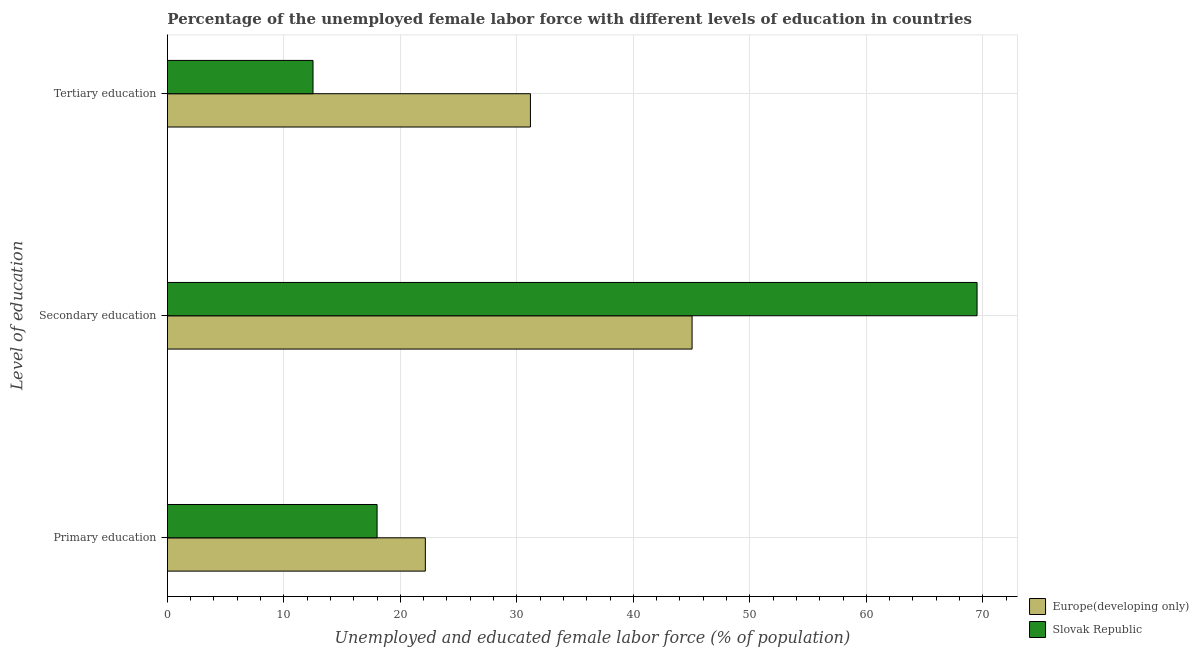How many different coloured bars are there?
Provide a short and direct response. 2. How many bars are there on the 3rd tick from the top?
Provide a succinct answer. 2. How many bars are there on the 2nd tick from the bottom?
Ensure brevity in your answer.  2. What is the percentage of female labor force who received tertiary education in Europe(developing only)?
Make the answer very short. 31.16. Across all countries, what is the maximum percentage of female labor force who received primary education?
Your answer should be compact. 22.14. In which country was the percentage of female labor force who received secondary education maximum?
Your answer should be very brief. Slovak Republic. In which country was the percentage of female labor force who received primary education minimum?
Make the answer very short. Slovak Republic. What is the total percentage of female labor force who received primary education in the graph?
Your answer should be very brief. 40.14. What is the difference between the percentage of female labor force who received tertiary education in Slovak Republic and that in Europe(developing only)?
Offer a terse response. -18.66. What is the difference between the percentage of female labor force who received tertiary education in Europe(developing only) and the percentage of female labor force who received secondary education in Slovak Republic?
Provide a short and direct response. -38.34. What is the average percentage of female labor force who received tertiary education per country?
Ensure brevity in your answer.  21.83. What is the difference between the percentage of female labor force who received secondary education and percentage of female labor force who received tertiary education in Europe(developing only)?
Your answer should be compact. 13.87. In how many countries, is the percentage of female labor force who received primary education greater than 34 %?
Your response must be concise. 0. What is the ratio of the percentage of female labor force who received tertiary education in Europe(developing only) to that in Slovak Republic?
Provide a succinct answer. 2.49. Is the percentage of female labor force who received primary education in Europe(developing only) less than that in Slovak Republic?
Provide a succinct answer. No. What is the difference between the highest and the second highest percentage of female labor force who received primary education?
Ensure brevity in your answer.  4.14. What is the difference between the highest and the lowest percentage of female labor force who received tertiary education?
Ensure brevity in your answer.  18.66. In how many countries, is the percentage of female labor force who received primary education greater than the average percentage of female labor force who received primary education taken over all countries?
Keep it short and to the point. 1. What does the 1st bar from the top in Tertiary education represents?
Your response must be concise. Slovak Republic. What does the 2nd bar from the bottom in Secondary education represents?
Offer a terse response. Slovak Republic. Is it the case that in every country, the sum of the percentage of female labor force who received primary education and percentage of female labor force who received secondary education is greater than the percentage of female labor force who received tertiary education?
Your answer should be compact. Yes. How many bars are there?
Provide a succinct answer. 6. How many countries are there in the graph?
Offer a terse response. 2. Does the graph contain any zero values?
Your answer should be very brief. No. What is the title of the graph?
Offer a terse response. Percentage of the unemployed female labor force with different levels of education in countries. What is the label or title of the X-axis?
Give a very brief answer. Unemployed and educated female labor force (% of population). What is the label or title of the Y-axis?
Your answer should be compact. Level of education. What is the Unemployed and educated female labor force (% of population) of Europe(developing only) in Primary education?
Provide a succinct answer. 22.14. What is the Unemployed and educated female labor force (% of population) in Slovak Republic in Primary education?
Offer a terse response. 18. What is the Unemployed and educated female labor force (% of population) in Europe(developing only) in Secondary education?
Your response must be concise. 45.04. What is the Unemployed and educated female labor force (% of population) of Slovak Republic in Secondary education?
Ensure brevity in your answer.  69.5. What is the Unemployed and educated female labor force (% of population) of Europe(developing only) in Tertiary education?
Provide a short and direct response. 31.16. Across all Level of education, what is the maximum Unemployed and educated female labor force (% of population) in Europe(developing only)?
Your response must be concise. 45.04. Across all Level of education, what is the maximum Unemployed and educated female labor force (% of population) in Slovak Republic?
Your response must be concise. 69.5. Across all Level of education, what is the minimum Unemployed and educated female labor force (% of population) in Europe(developing only)?
Your response must be concise. 22.14. What is the total Unemployed and educated female labor force (% of population) of Europe(developing only) in the graph?
Offer a terse response. 98.34. What is the difference between the Unemployed and educated female labor force (% of population) in Europe(developing only) in Primary education and that in Secondary education?
Offer a very short reply. -22.9. What is the difference between the Unemployed and educated female labor force (% of population) of Slovak Republic in Primary education and that in Secondary education?
Keep it short and to the point. -51.5. What is the difference between the Unemployed and educated female labor force (% of population) in Europe(developing only) in Primary education and that in Tertiary education?
Give a very brief answer. -9.02. What is the difference between the Unemployed and educated female labor force (% of population) in Slovak Republic in Primary education and that in Tertiary education?
Your response must be concise. 5.5. What is the difference between the Unemployed and educated female labor force (% of population) of Europe(developing only) in Secondary education and that in Tertiary education?
Your answer should be compact. 13.87. What is the difference between the Unemployed and educated female labor force (% of population) in Europe(developing only) in Primary education and the Unemployed and educated female labor force (% of population) in Slovak Republic in Secondary education?
Provide a succinct answer. -47.36. What is the difference between the Unemployed and educated female labor force (% of population) of Europe(developing only) in Primary education and the Unemployed and educated female labor force (% of population) of Slovak Republic in Tertiary education?
Your answer should be compact. 9.64. What is the difference between the Unemployed and educated female labor force (% of population) of Europe(developing only) in Secondary education and the Unemployed and educated female labor force (% of population) of Slovak Republic in Tertiary education?
Ensure brevity in your answer.  32.54. What is the average Unemployed and educated female labor force (% of population) of Europe(developing only) per Level of education?
Provide a succinct answer. 32.78. What is the average Unemployed and educated female labor force (% of population) in Slovak Republic per Level of education?
Your answer should be very brief. 33.33. What is the difference between the Unemployed and educated female labor force (% of population) in Europe(developing only) and Unemployed and educated female labor force (% of population) in Slovak Republic in Primary education?
Your answer should be very brief. 4.14. What is the difference between the Unemployed and educated female labor force (% of population) of Europe(developing only) and Unemployed and educated female labor force (% of population) of Slovak Republic in Secondary education?
Your response must be concise. -24.46. What is the difference between the Unemployed and educated female labor force (% of population) of Europe(developing only) and Unemployed and educated female labor force (% of population) of Slovak Republic in Tertiary education?
Provide a succinct answer. 18.66. What is the ratio of the Unemployed and educated female labor force (% of population) in Europe(developing only) in Primary education to that in Secondary education?
Your answer should be very brief. 0.49. What is the ratio of the Unemployed and educated female labor force (% of population) in Slovak Republic in Primary education to that in Secondary education?
Offer a very short reply. 0.26. What is the ratio of the Unemployed and educated female labor force (% of population) of Europe(developing only) in Primary education to that in Tertiary education?
Your response must be concise. 0.71. What is the ratio of the Unemployed and educated female labor force (% of population) of Slovak Republic in Primary education to that in Tertiary education?
Give a very brief answer. 1.44. What is the ratio of the Unemployed and educated female labor force (% of population) of Europe(developing only) in Secondary education to that in Tertiary education?
Offer a very short reply. 1.45. What is the ratio of the Unemployed and educated female labor force (% of population) of Slovak Republic in Secondary education to that in Tertiary education?
Your answer should be compact. 5.56. What is the difference between the highest and the second highest Unemployed and educated female labor force (% of population) of Europe(developing only)?
Offer a very short reply. 13.87. What is the difference between the highest and the second highest Unemployed and educated female labor force (% of population) of Slovak Republic?
Provide a short and direct response. 51.5. What is the difference between the highest and the lowest Unemployed and educated female labor force (% of population) of Europe(developing only)?
Provide a short and direct response. 22.9. What is the difference between the highest and the lowest Unemployed and educated female labor force (% of population) in Slovak Republic?
Provide a succinct answer. 57. 